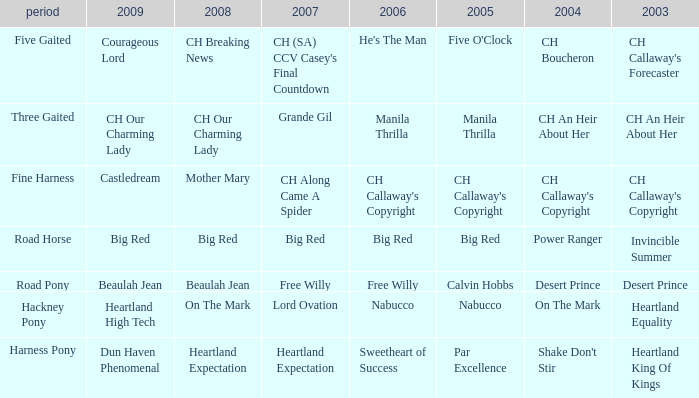What is the 2008 for 2009 heartland high tech? On The Mark. 